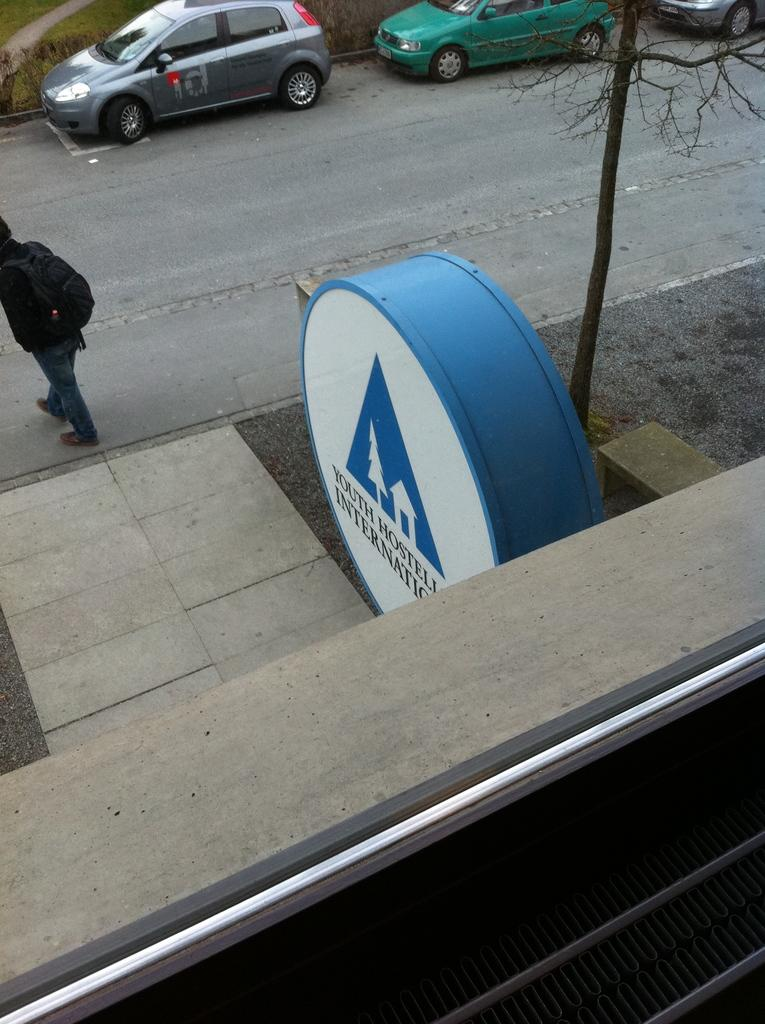What is the color of the object in the image? The object in the image is white and blue. What is featured on the object? There is writing on the object. Where is the person in the image located? The person is standing in the left corner of the image. What can be seen on the road in the image? There are vehicles on the road in the image. What type of kettle is being used by the laborer in the image? There is no kettle or laborer present in the image. Who is the partner of the person standing in the image? There is no partner mentioned or visible in the image. 